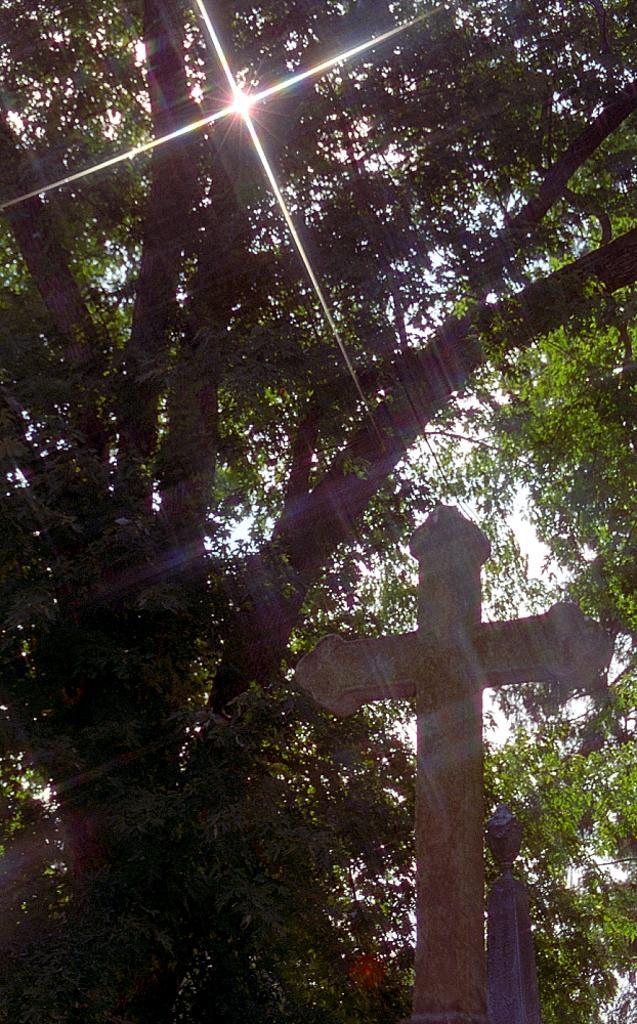In one or two sentences, can you explain what this image depicts? In this image in the foreground there is one cross, and in the background there are some trees and sky. 